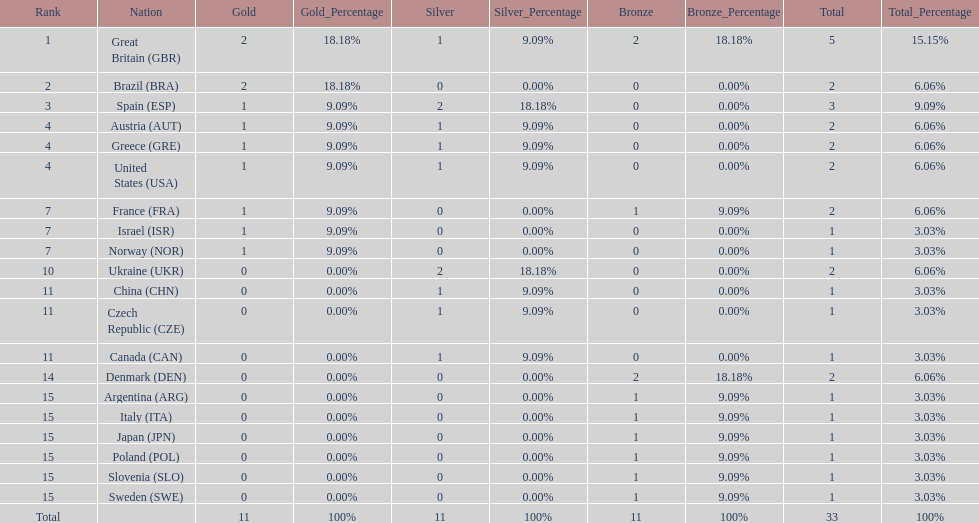How many countries won at least 2 medals in sailing? 9. 